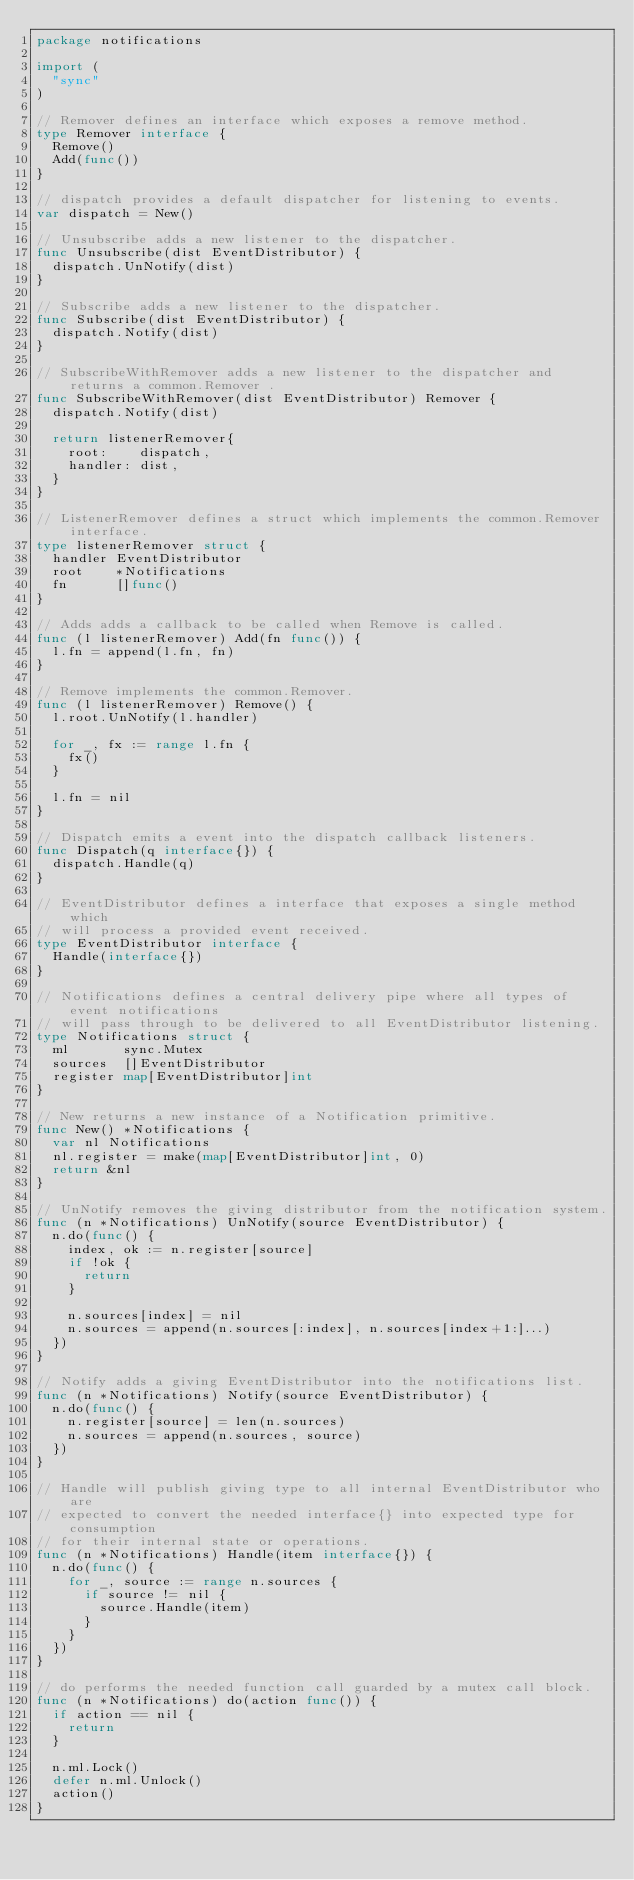Convert code to text. <code><loc_0><loc_0><loc_500><loc_500><_Go_>package notifications

import (
	"sync"
)

// Remover defines an interface which exposes a remove method.
type Remover interface {
	Remove()
	Add(func())
}

// dispatch provides a default dispatcher for listening to events.
var dispatch = New()

// Unsubscribe adds a new listener to the dispatcher.
func Unsubscribe(dist EventDistributor) {
	dispatch.UnNotify(dist)
}

// Subscribe adds a new listener to the dispatcher.
func Subscribe(dist EventDistributor) {
	dispatch.Notify(dist)
}

// SubscribeWithRemover adds a new listener to the dispatcher and returns a common.Remover .
func SubscribeWithRemover(dist EventDistributor) Remover {
	dispatch.Notify(dist)

	return listenerRemover{
		root:    dispatch,
		handler: dist,
	}
}

// ListenerRemover defines a struct which implements the common.Remover interface.
type listenerRemover struct {
	handler EventDistributor
	root    *Notifications
	fn      []func()
}

// Adds adds a callback to be called when Remove is called.
func (l listenerRemover) Add(fn func()) {
	l.fn = append(l.fn, fn)
}

// Remove implements the common.Remover.
func (l listenerRemover) Remove() {
	l.root.UnNotify(l.handler)

	for _, fx := range l.fn {
		fx()
	}

	l.fn = nil
}

// Dispatch emits a event into the dispatch callback listeners.
func Dispatch(q interface{}) {
	dispatch.Handle(q)
}

// EventDistributor defines a interface that exposes a single method which
// will process a provided event received.
type EventDistributor interface {
	Handle(interface{})
}

// Notifications defines a central delivery pipe where all types of event notifications
// will pass through to be delivered to all EventDistributor listening.
type Notifications struct {
	ml       sync.Mutex
	sources  []EventDistributor
	register map[EventDistributor]int
}

// New returns a new instance of a Notification primitive.
func New() *Notifications {
	var nl Notifications
	nl.register = make(map[EventDistributor]int, 0)
	return &nl
}

// UnNotify removes the giving distributor from the notification system.
func (n *Notifications) UnNotify(source EventDistributor) {
	n.do(func() {
		index, ok := n.register[source]
		if !ok {
			return
		}

		n.sources[index] = nil
		n.sources = append(n.sources[:index], n.sources[index+1:]...)
	})
}

// Notify adds a giving EventDistributor into the notifications list.
func (n *Notifications) Notify(source EventDistributor) {
	n.do(func() {
		n.register[source] = len(n.sources)
		n.sources = append(n.sources, source)
	})
}

// Handle will publish giving type to all internal EventDistributor who are
// expected to convert the needed interface{} into expected type for consumption
// for their internal state or operations.
func (n *Notifications) Handle(item interface{}) {
	n.do(func() {
		for _, source := range n.sources {
			if source != nil {
				source.Handle(item)
			}
		}
	})
}

// do performs the needed function call guarded by a mutex call block.
func (n *Notifications) do(action func()) {
	if action == nil {
		return
	}

	n.ml.Lock()
	defer n.ml.Unlock()
	action()
}
</code> 